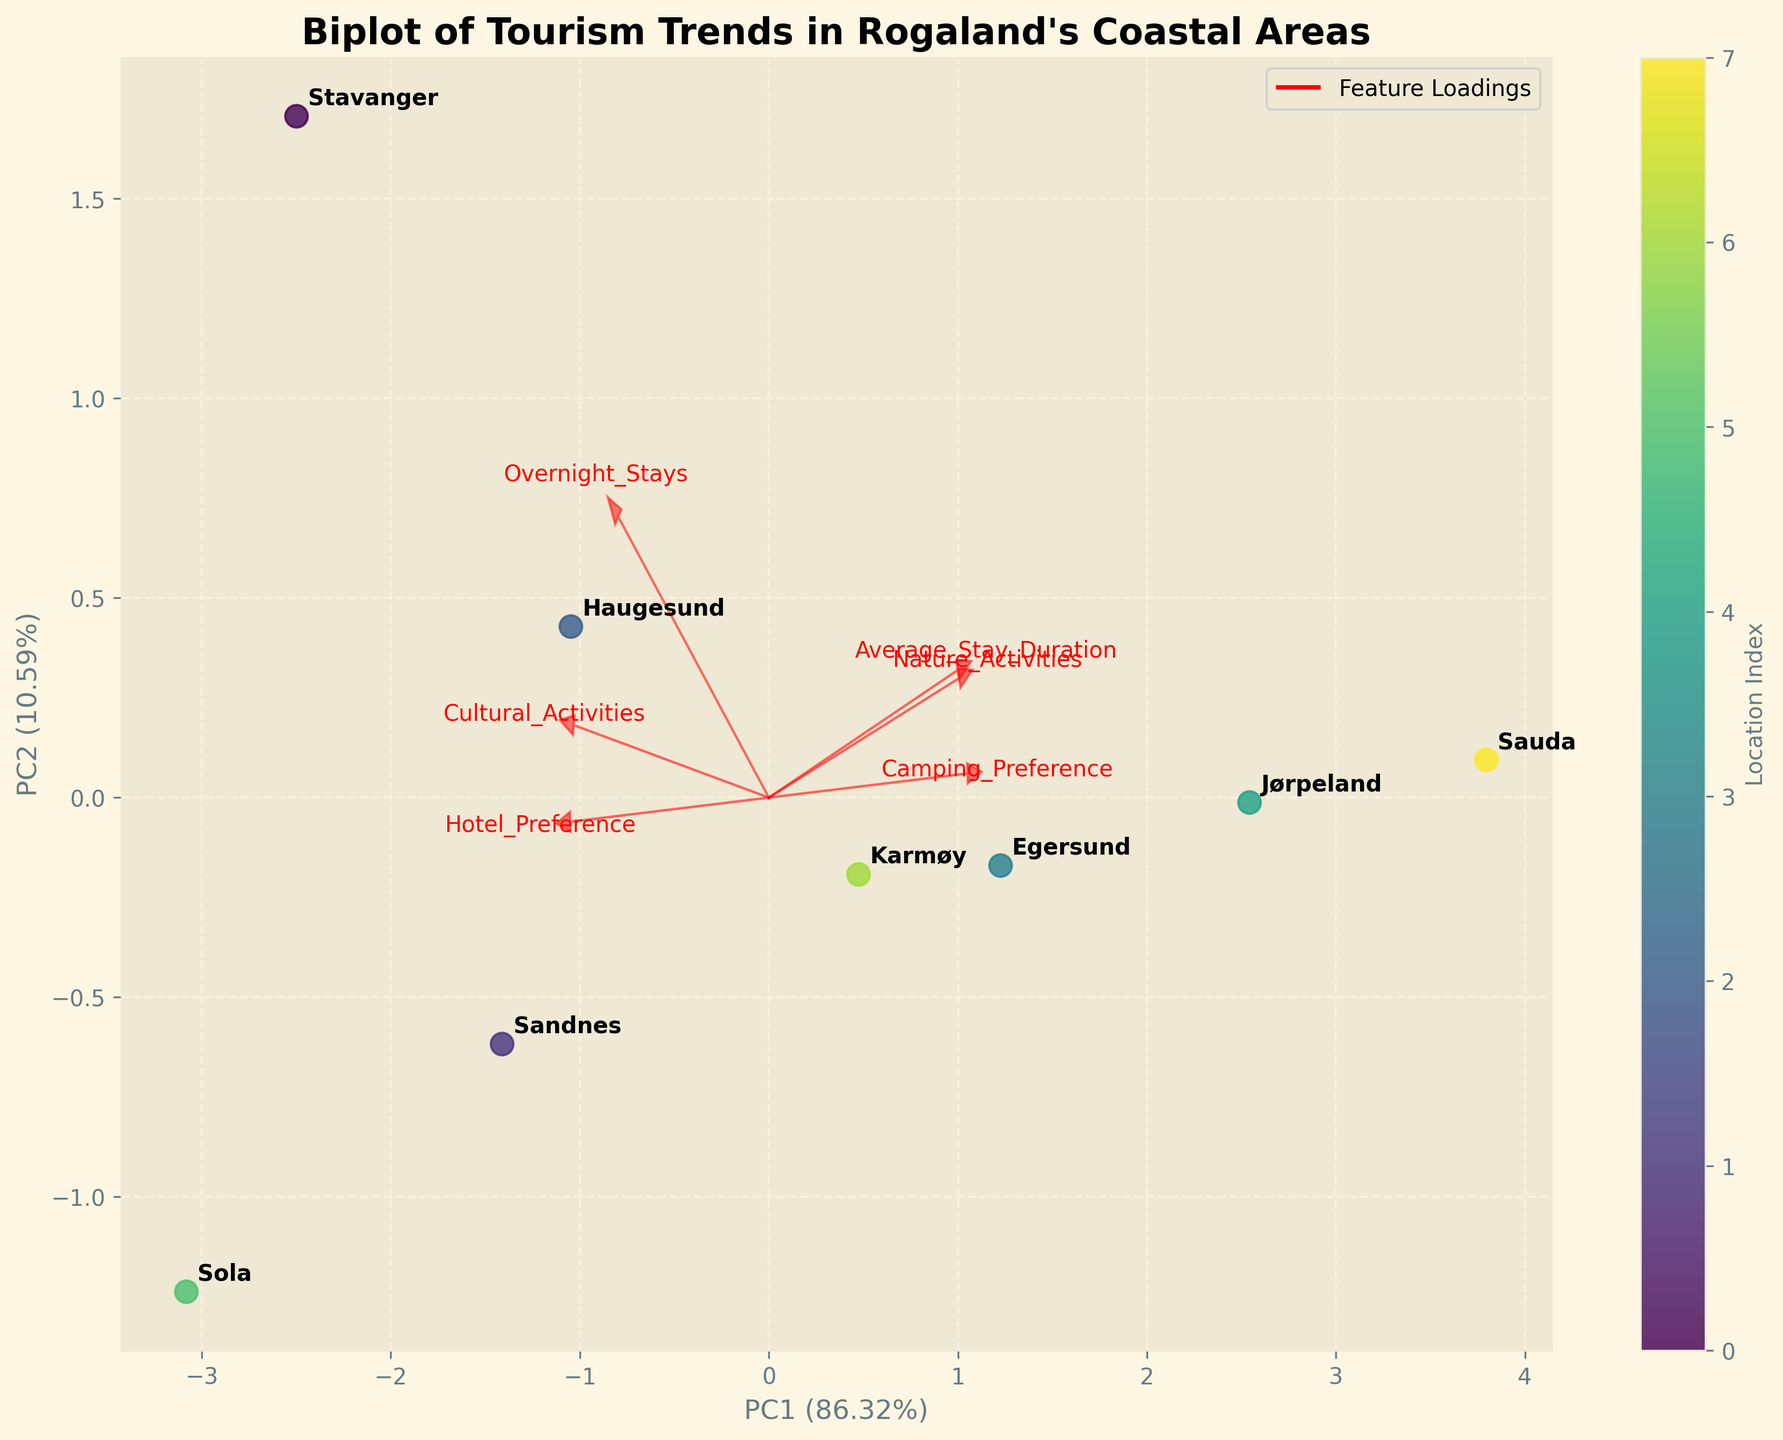what is the title of the plot? The title is located at the top center of the biplot and describes the content of the plot. The title reads, "Biplot of Tourism Trends in Rogaland's Coastal Areas".
Answer: Biplot of Tourism Trends in Rogaland's Coastal Areas How many data points are displayed in the biplot? To find the number of data points, count the individual points annotated with the location names. There are eight points corresponding to the locations Stavanger, Sandnes, Haugesund, Egersund, Jørpeland, Sola, Karmøy, and Sauda.
Answer: 8 What feature is associated with the highest positive loading along PC1? PC1 is the horizontal axis in the biplot. Features with arrows pointing farthest to the right (positive direction) along this axis have the highest loading. Let's examine and find the feature with the largest horizontal extension.
Answer: Overnight_Stays Which location has the highest PC1 score? To determine the highest PC1 score, check which location is positioned farthest to the right along the horizontal axis. "Stavanger" appears to be the farthest location along PC1.
Answer: Stavanger Which two features are most strongly correlated based on the loadings shown on the biplot? Correlation between features is indicated by how closely together their arrows point in the same direction. The arrows for "Nature_Activities" and "Average_Stay_Duration" are closely aligned and point in the same general direction, indicating a strong relationship.
Answer: Nature_Activities and Average_Stay_Duration Which location has the highest preference for camping? Locations with high campsite preference would plot further in the direction of the "Camping_Preference" loading. Sauda, represented by a data point, is furthest in the direction of this arrow, indicating high camping preference.
Answer: Sauda How much of the total variance is explained by PC1 and PC2 combined? The percentage of variance explained by PC1 and PC2 is typically provided in parentheses next to their respective axis labels. According to the biplot, PC1 explains 48% and PC2 explains 33% of the variance. The combined variance is 48% + 33% = 81%.
Answer: 81% Which feature has the smallest contribution to PC2, and what is the implication for the biplot? The smallest contribution to PC2 is seen in the arrow with the shortest vertical length or presence along the vertical axis. "Average_Stay_Duration" appears to have minimal vertical influence, implying it contributes little to PC2.
Answer: Average_Stay_Duration Which locations have similar overnight stays characteristics, based on their positions in the biplot? Locations that cluster together in the biplot share similar characteristics. Sandnes and Sola appear close together. This proximity indicates similarly in the context of overnight stays and perhaps other features.
Answer: Sandnes and Sola What insight can we gain about Egersund from its biplot position relative to other locations? Egersund has a notable projection along both PC1 and PC2, illustrating specific characteristics like a balanced preference for camping and nature activities. Its distance from other points reflects unique attributes like a possibly longer average stay duration.
Answer: Unique in nature activities and balanced accommodation preferences 